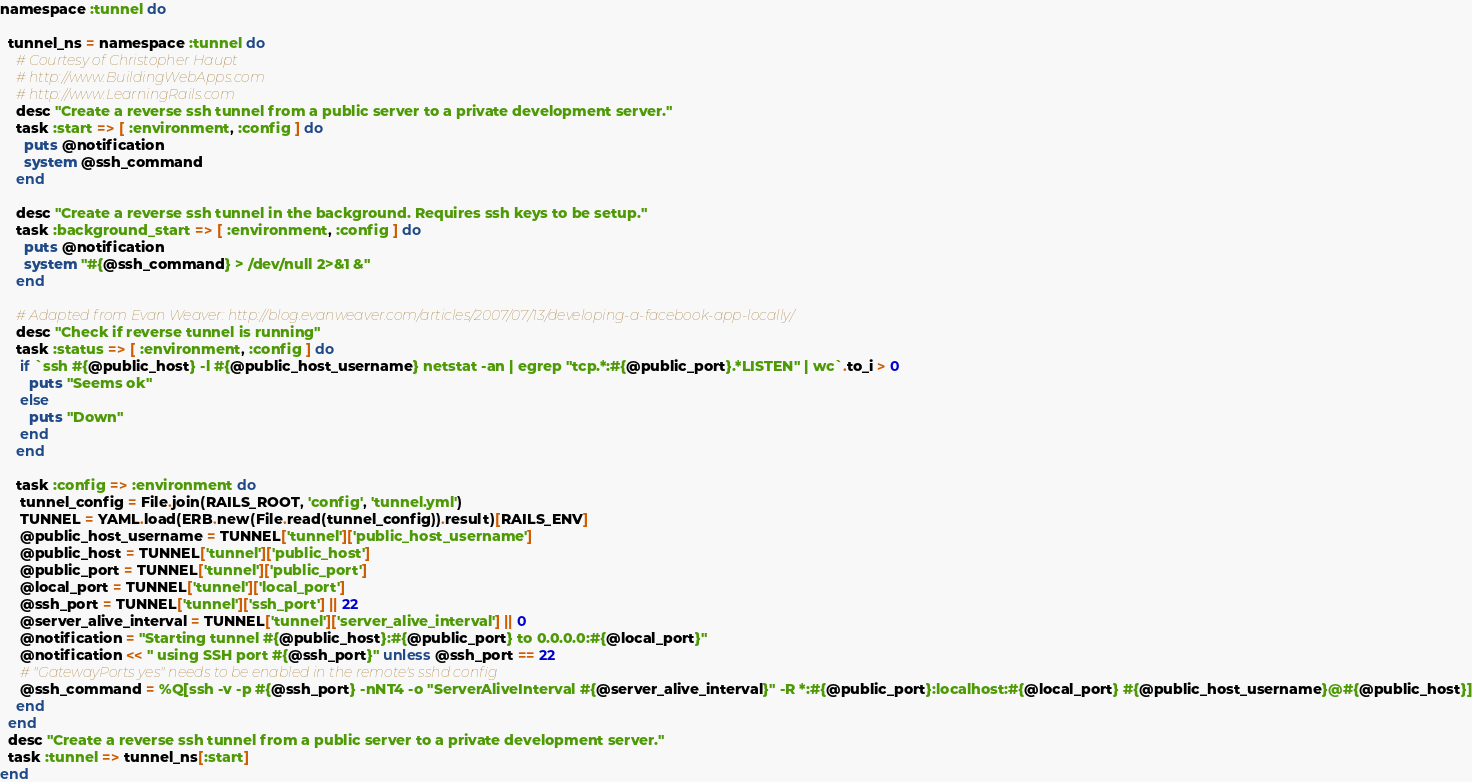Convert code to text. <code><loc_0><loc_0><loc_500><loc_500><_Ruby_>namespace :tunnel do

  tunnel_ns = namespace :tunnel do
    # Courtesy of Christopher Haupt
    # http://www.BuildingWebApps.com
    # http://www.LearningRails.com
    desc "Create a reverse ssh tunnel from a public server to a private development server."
    task :start => [ :environment, :config ] do
      puts @notification
      system @ssh_command
    end

    desc "Create a reverse ssh tunnel in the background. Requires ssh keys to be setup."
    task :background_start => [ :environment, :config ] do
      puts @notification
      system "#{@ssh_command} > /dev/null 2>&1 &"
    end

    # Adapted from Evan Weaver: http://blog.evanweaver.com/articles/2007/07/13/developing-a-facebook-app-locally/
    desc "Check if reverse tunnel is running"
    task :status => [ :environment, :config ] do
     if `ssh #{@public_host} -l #{@public_host_username} netstat -an | egrep "tcp.*:#{@public_port}.*LISTEN" | wc`.to_i > 0
       puts "Seems ok"
     else
       puts "Down"
     end
    end

    task :config => :environment do
     tunnel_config = File.join(RAILS_ROOT, 'config', 'tunnel.yml')
     TUNNEL = YAML.load(ERB.new(File.read(tunnel_config)).result)[RAILS_ENV]
     @public_host_username = TUNNEL['tunnel']['public_host_username']
     @public_host = TUNNEL['tunnel']['public_host']
     @public_port = TUNNEL['tunnel']['public_port']
     @local_port = TUNNEL['tunnel']['local_port']
     @ssh_port = TUNNEL['tunnel']['ssh_port'] || 22
     @server_alive_interval = TUNNEL['tunnel']['server_alive_interval'] || 0
     @notification = "Starting tunnel #{@public_host}:#{@public_port} to 0.0.0.0:#{@local_port}"
     @notification << " using SSH port #{@ssh_port}" unless @ssh_port == 22
     # "GatewayPorts yes" needs to be enabled in the remote's sshd config
     @ssh_command = %Q[ssh -v -p #{@ssh_port} -nNT4 -o "ServerAliveInterval #{@server_alive_interval}" -R *:#{@public_port}:localhost:#{@local_port} #{@public_host_username}@#{@public_host}]
    end
  end
  desc "Create a reverse ssh tunnel from a public server to a private development server."
  task :tunnel => tunnel_ns[:start]
end
</code> 